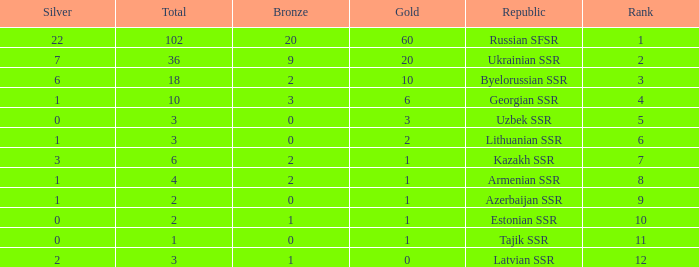What is the total number of bronzes associated with 1 silver, ranks under 6 and under 6 golds? None. 